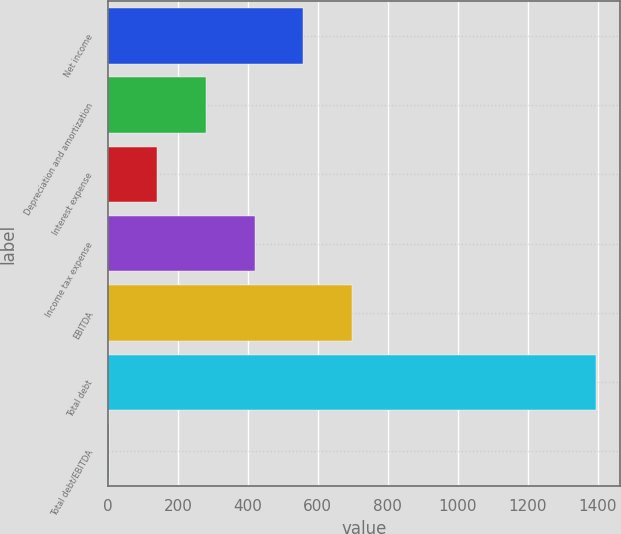Convert chart to OTSL. <chart><loc_0><loc_0><loc_500><loc_500><bar_chart><fcel>Net income<fcel>Depreciation and amortization<fcel>Interest expense<fcel>Income tax expense<fcel>EBITDA<fcel>Total debt<fcel>Total debt/EBITDA<nl><fcel>558.97<fcel>280.49<fcel>141.25<fcel>419.73<fcel>698.21<fcel>1394.4<fcel>2.01<nl></chart> 